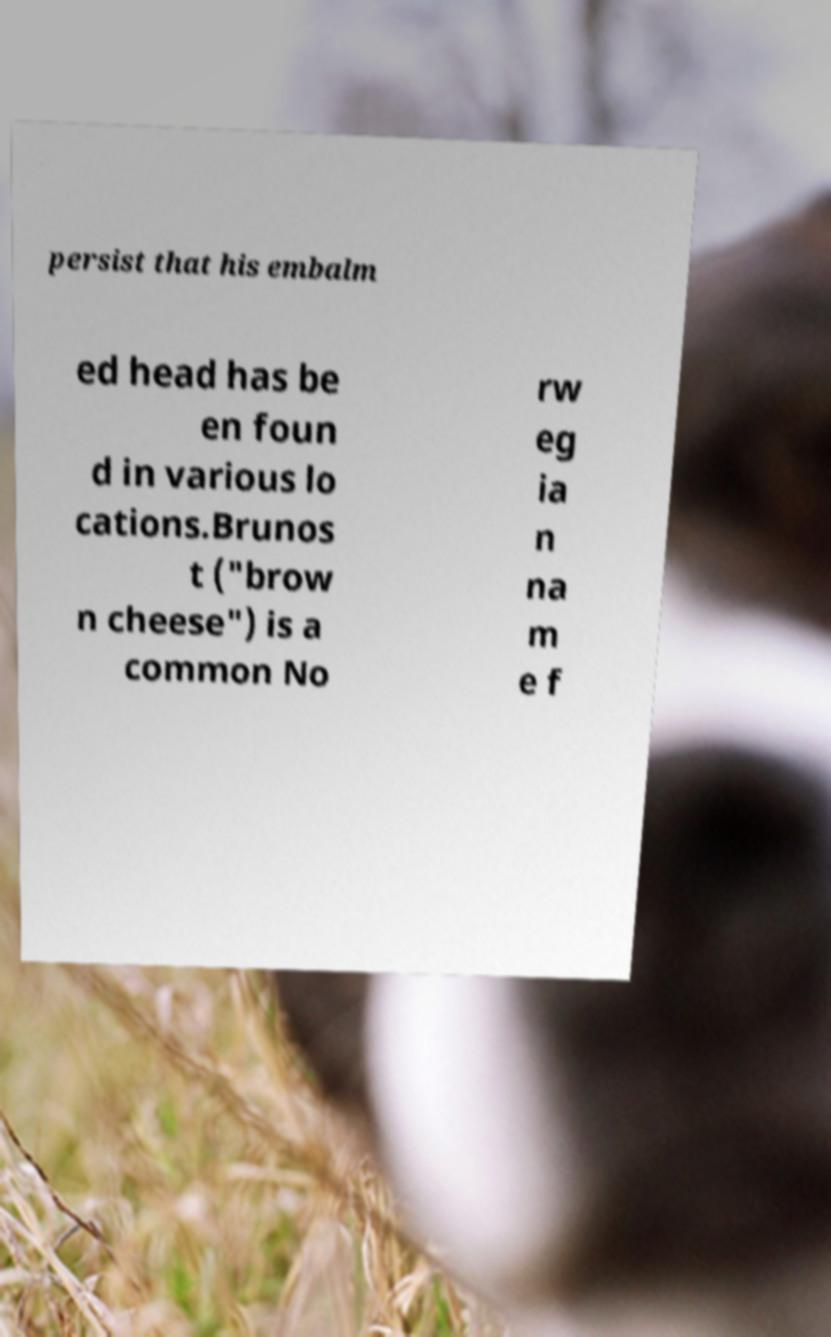Please read and relay the text visible in this image. What does it say? persist that his embalm ed head has be en foun d in various lo cations.Brunos t ("brow n cheese") is a common No rw eg ia n na m e f 